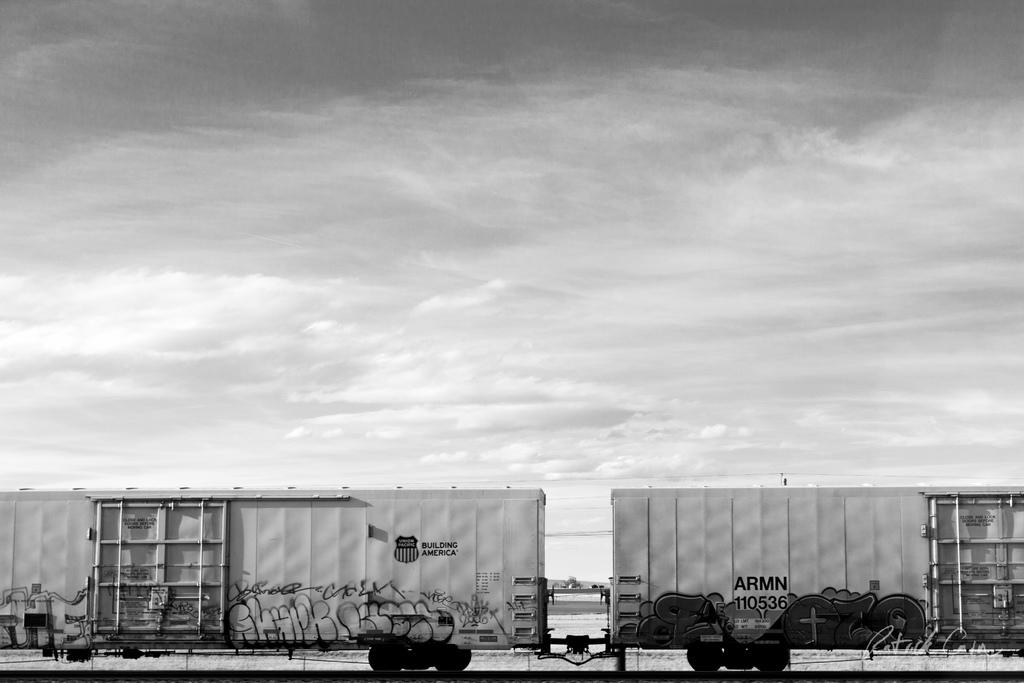What is the color scheme of the image? The image is in black and white. What can be seen at the bottom of the image? There is a train on the track at the bottom of the image. What is featured on the train? The train has pictures and text on it. What is visible in the background of the image? There is a sky with clouds in the background of the image. Can you see the moon in the image? No, the moon is not visible in the image; only a sky with clouds can be seen in the background. What type of transport is used to move the train in the image? The image does not show the train moving, so it is not possible to determine the type of transport used. 